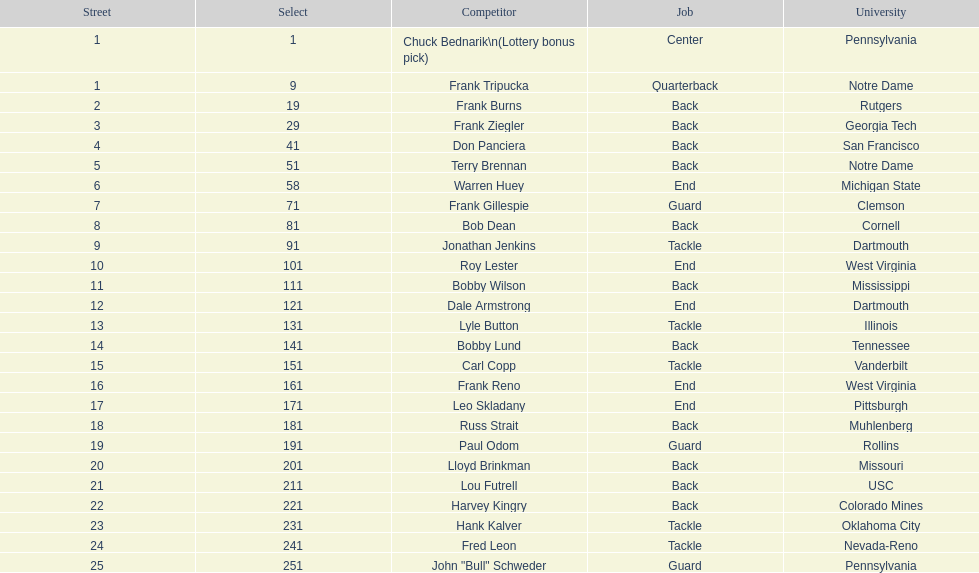Who was picked after roy lester? Bobby Wilson. 